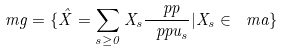<formula> <loc_0><loc_0><loc_500><loc_500>\ m g = \{ \hat { X } = \sum _ { s \geq 0 } X _ { s } \frac { \ p p } { \ p p u _ { s } } | X _ { s } \in \ m a \}</formula> 